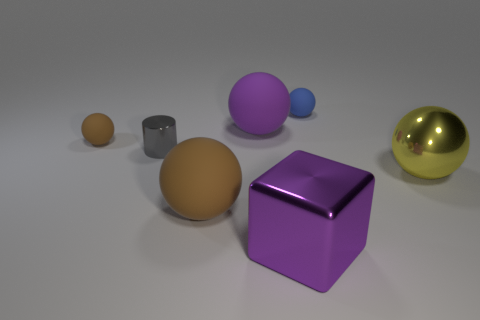Subtract 1 spheres. How many spheres are left? 4 Subtract all gray balls. Subtract all cyan cylinders. How many balls are left? 5 Add 3 large cyan cylinders. How many objects exist? 10 Subtract all spheres. How many objects are left? 2 Add 2 purple objects. How many purple objects exist? 4 Subtract 0 cyan spheres. How many objects are left? 7 Subtract all green balls. Subtract all brown balls. How many objects are left? 5 Add 6 tiny matte things. How many tiny matte things are left? 8 